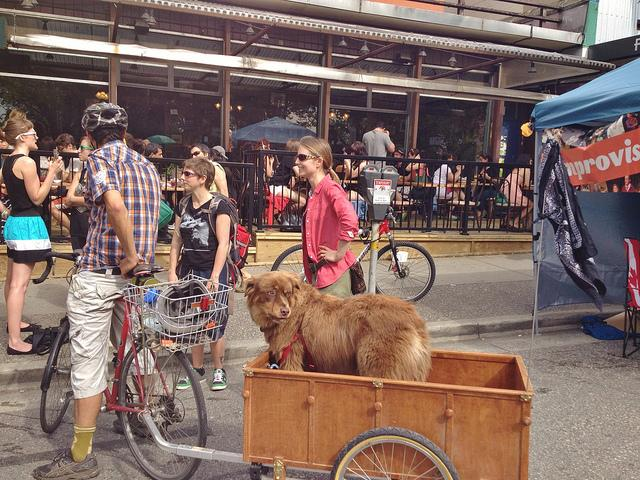What is the dog riding in? cart 